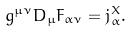Convert formula to latex. <formula><loc_0><loc_0><loc_500><loc_500>g ^ { \mu \nu } D _ { \mu } F _ { \alpha \nu } = j ^ { X } _ { \alpha } .</formula> 